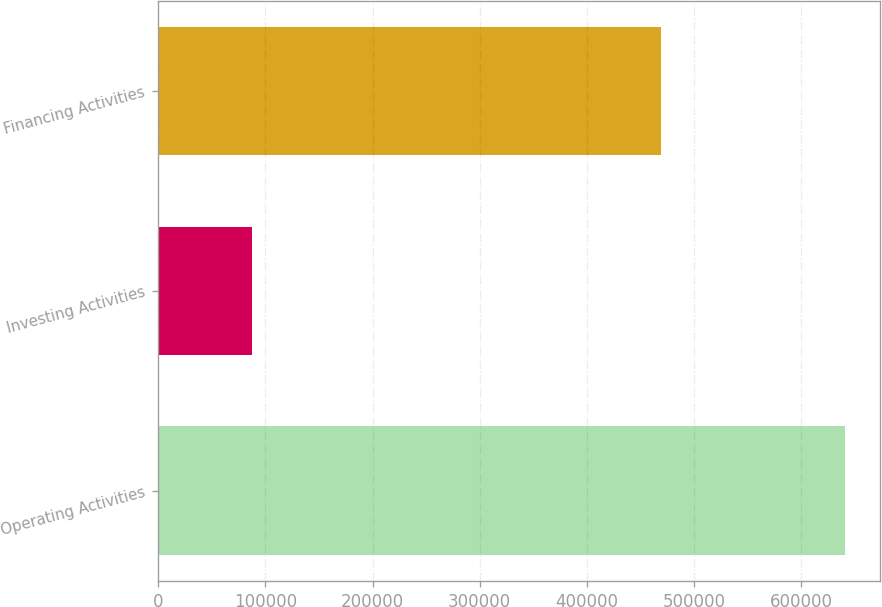Convert chart. <chart><loc_0><loc_0><loc_500><loc_500><bar_chart><fcel>Operating Activities<fcel>Investing Activities<fcel>Financing Activities<nl><fcel>641471<fcel>87598<fcel>469496<nl></chart> 